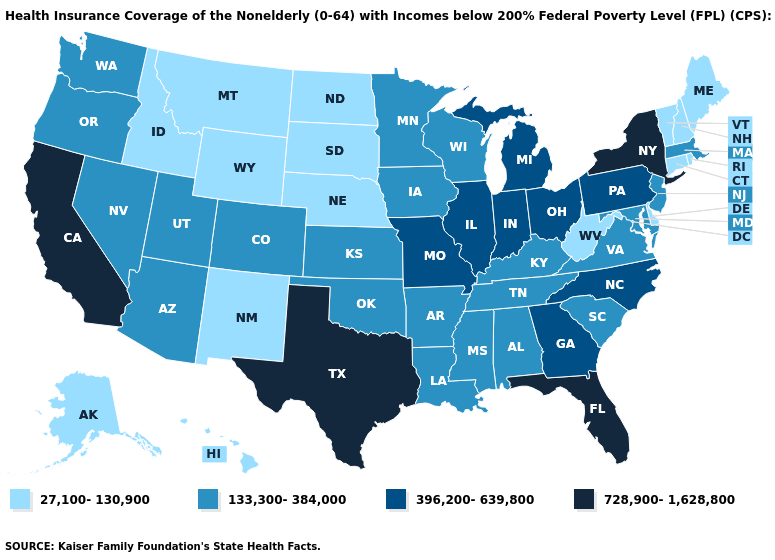Which states hav the highest value in the West?
Quick response, please. California. What is the lowest value in states that border New Mexico?
Write a very short answer. 133,300-384,000. What is the value of Nevada?
Concise answer only. 133,300-384,000. What is the value of Wisconsin?
Quick response, please. 133,300-384,000. Does Illinois have the highest value in the USA?
Short answer required. No. What is the value of Indiana?
Short answer required. 396,200-639,800. Does Delaware have the highest value in the South?
Write a very short answer. No. Does the first symbol in the legend represent the smallest category?
Write a very short answer. Yes. Does New York have the highest value in the Northeast?
Quick response, please. Yes. What is the highest value in states that border Iowa?
Short answer required. 396,200-639,800. What is the value of Arkansas?
Be succinct. 133,300-384,000. Name the states that have a value in the range 27,100-130,900?
Be succinct. Alaska, Connecticut, Delaware, Hawaii, Idaho, Maine, Montana, Nebraska, New Hampshire, New Mexico, North Dakota, Rhode Island, South Dakota, Vermont, West Virginia, Wyoming. Name the states that have a value in the range 728,900-1,628,800?
Be succinct. California, Florida, New York, Texas. Name the states that have a value in the range 133,300-384,000?
Give a very brief answer. Alabama, Arizona, Arkansas, Colorado, Iowa, Kansas, Kentucky, Louisiana, Maryland, Massachusetts, Minnesota, Mississippi, Nevada, New Jersey, Oklahoma, Oregon, South Carolina, Tennessee, Utah, Virginia, Washington, Wisconsin. Name the states that have a value in the range 396,200-639,800?
Answer briefly. Georgia, Illinois, Indiana, Michigan, Missouri, North Carolina, Ohio, Pennsylvania. 